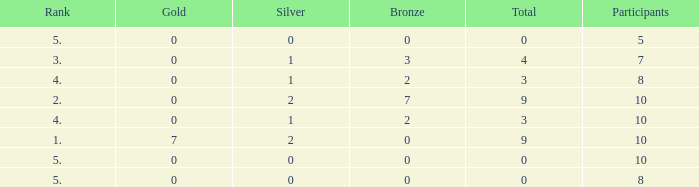What is the total number of Participants that has Silver that's smaller than 0? None. 